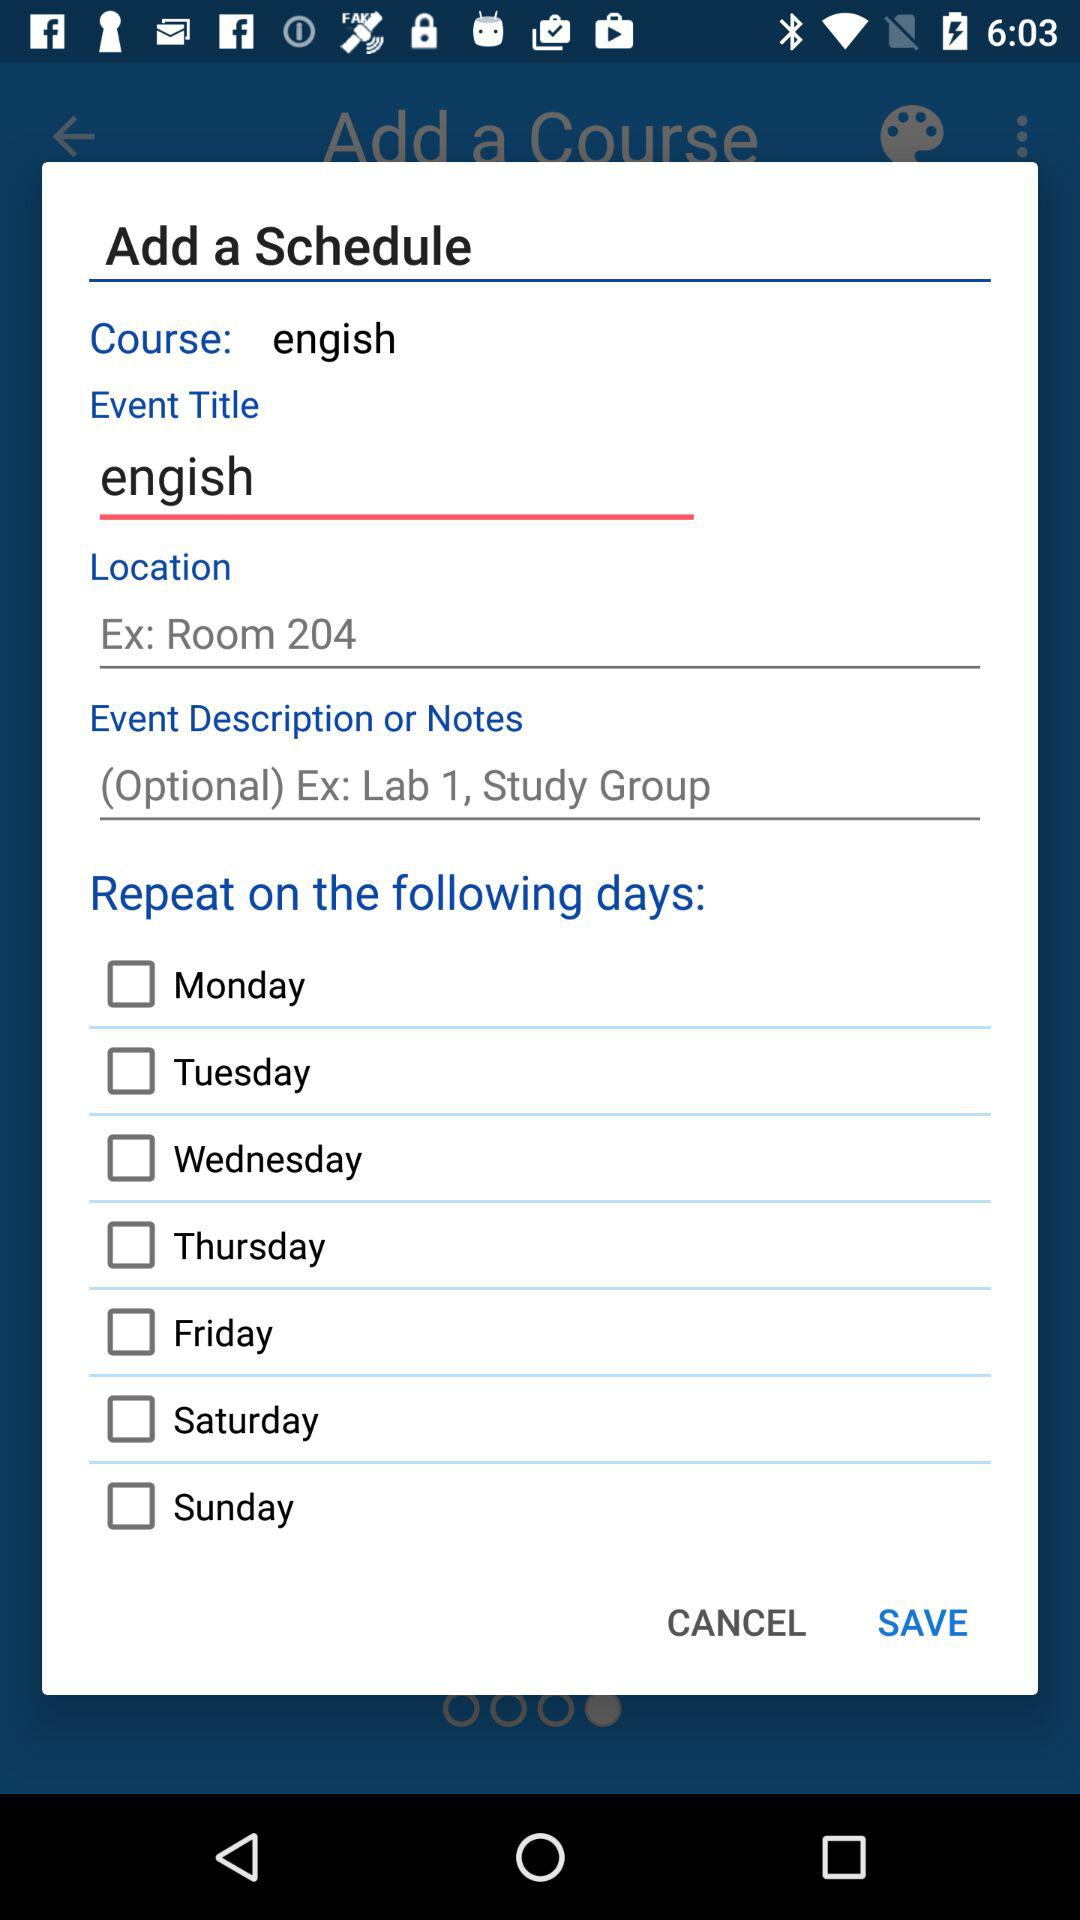What is the name of the course? The name of the course is "engish". 